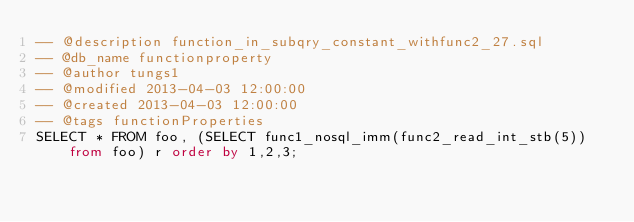<code> <loc_0><loc_0><loc_500><loc_500><_SQL_>-- @description function_in_subqry_constant_withfunc2_27.sql
-- @db_name functionproperty
-- @author tungs1
-- @modified 2013-04-03 12:00:00
-- @created 2013-04-03 12:00:00
-- @tags functionProperties 
SELECT * FROM foo, (SELECT func1_nosql_imm(func2_read_int_stb(5)) from foo) r order by 1,2,3; 
</code> 